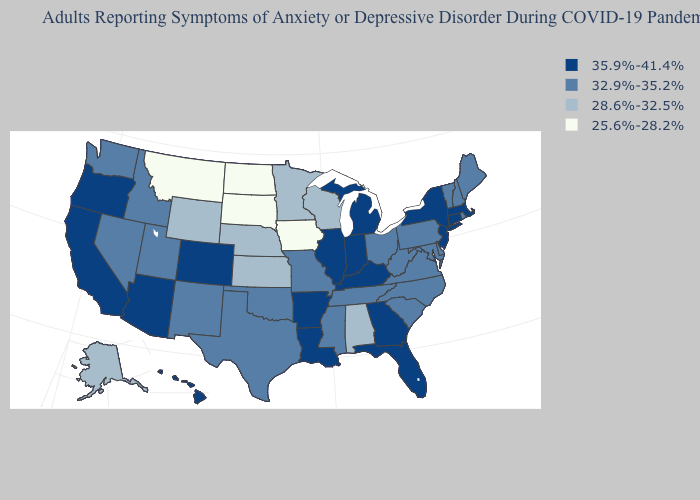Does Rhode Island have the lowest value in the Northeast?
Answer briefly. Yes. What is the value of Alaska?
Write a very short answer. 28.6%-32.5%. What is the value of Michigan?
Give a very brief answer. 35.9%-41.4%. Among the states that border Indiana , which have the highest value?
Concise answer only. Illinois, Kentucky, Michigan. Name the states that have a value in the range 25.6%-28.2%?
Short answer required. Iowa, Montana, North Dakota, South Dakota. Name the states that have a value in the range 25.6%-28.2%?
Short answer required. Iowa, Montana, North Dakota, South Dakota. Name the states that have a value in the range 35.9%-41.4%?
Write a very short answer. Arizona, Arkansas, California, Colorado, Connecticut, Florida, Georgia, Hawaii, Illinois, Indiana, Kentucky, Louisiana, Massachusetts, Michigan, New Jersey, New York, Oregon. What is the value of Washington?
Answer briefly. 32.9%-35.2%. What is the lowest value in states that border Utah?
Keep it brief. 28.6%-32.5%. How many symbols are there in the legend?
Quick response, please. 4. Name the states that have a value in the range 32.9%-35.2%?
Short answer required. Delaware, Idaho, Maine, Maryland, Mississippi, Missouri, Nevada, New Hampshire, New Mexico, North Carolina, Ohio, Oklahoma, Pennsylvania, Rhode Island, South Carolina, Tennessee, Texas, Utah, Vermont, Virginia, Washington, West Virginia. What is the lowest value in the MidWest?
Be succinct. 25.6%-28.2%. What is the value of Maryland?
Be succinct. 32.9%-35.2%. Among the states that border California , does Oregon have the highest value?
Keep it brief. Yes. 